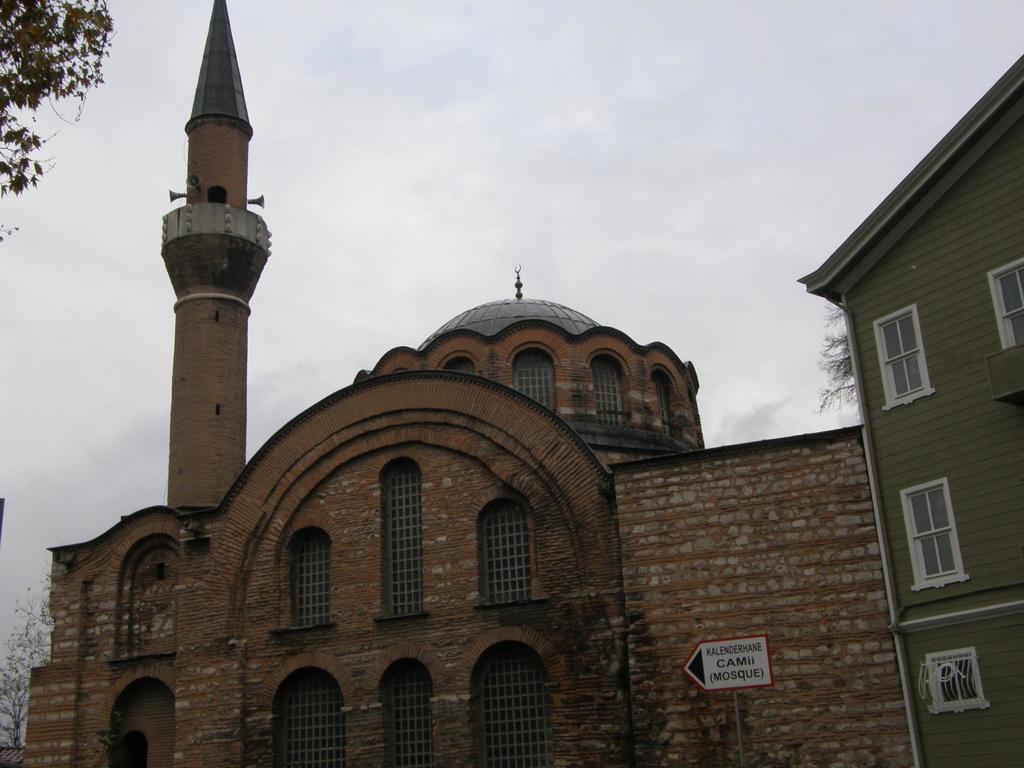In one or two sentences, can you explain what this image depicts? In this image in the center there is one mosque, and beside the mosque there is one house on the left side there are some trees. On the top of the image there is sky. 